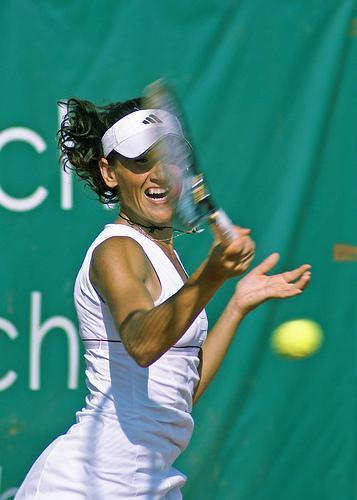How many women holding a racket?
Give a very brief answer. 1. 